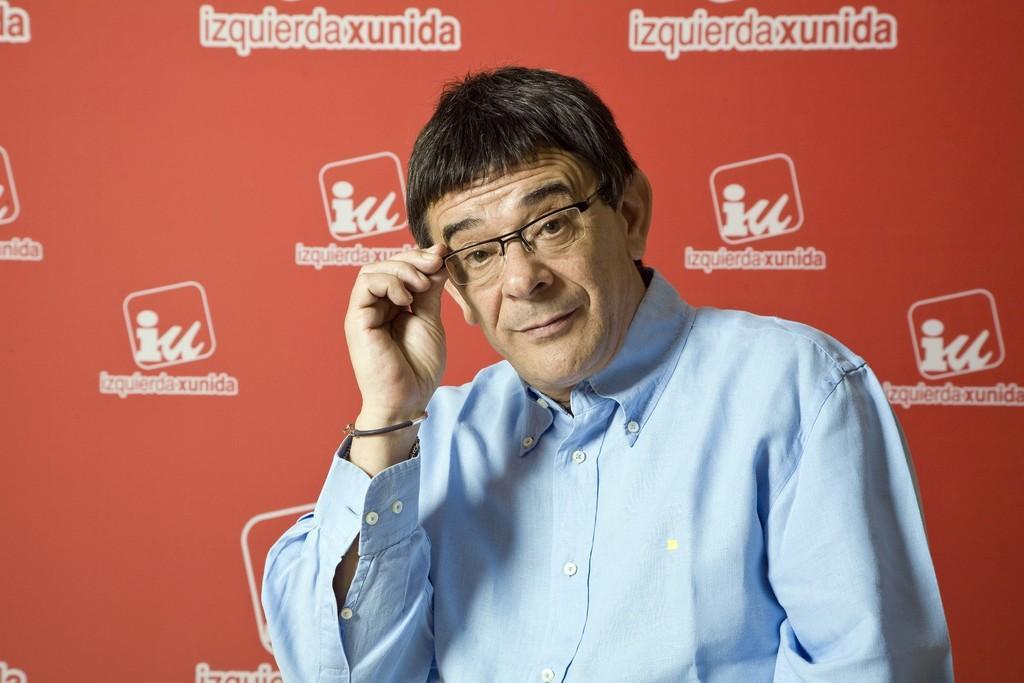How would you summarize this image in a sentence or two? In this image we can see a man wearing glasses. In the background there is a board. 